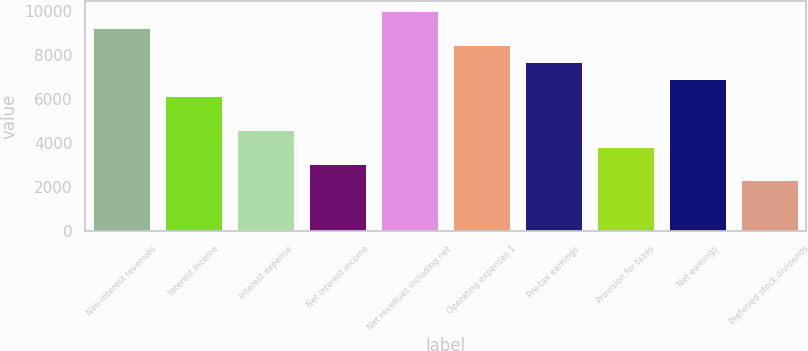<chart> <loc_0><loc_0><loc_500><loc_500><bar_chart><fcel>Non-interest revenues<fcel>Interest income<fcel>Interest expense<fcel>Net interest income<fcel>Net revenues including net<fcel>Operating expenses 1<fcel>Pre-tax earnings<fcel>Provision for taxes<fcel>Net earnings<fcel>Preferred stock dividends<nl><fcel>9225.48<fcel>6150.52<fcel>4613.04<fcel>3075.56<fcel>9994.22<fcel>8456.74<fcel>7688<fcel>3844.3<fcel>6919.26<fcel>2306.82<nl></chart> 